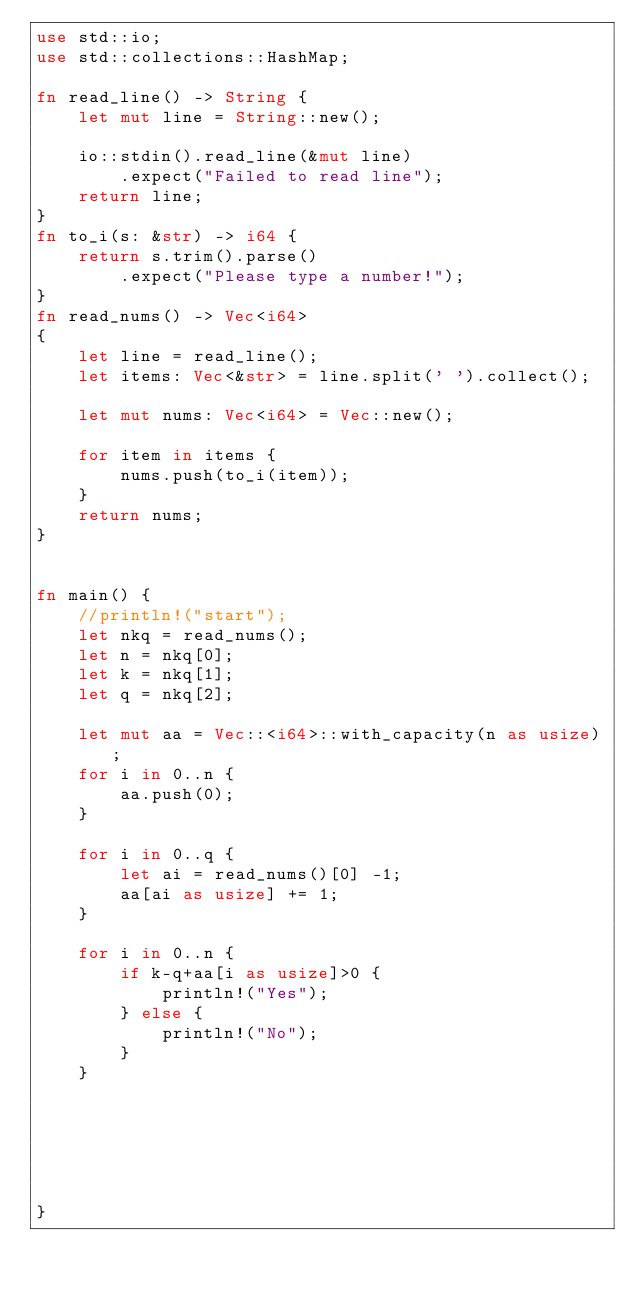Convert code to text. <code><loc_0><loc_0><loc_500><loc_500><_Rust_>use std::io;
use std::collections::HashMap;

fn read_line() -> String {
    let mut line = String::new();

    io::stdin().read_line(&mut line)
        .expect("Failed to read line");
    return line;
}
fn to_i(s: &str) -> i64 {
    return s.trim().parse()
        .expect("Please type a number!");
}
fn read_nums() -> Vec<i64>
{
    let line = read_line();
    let items: Vec<&str> = line.split(' ').collect();

    let mut nums: Vec<i64> = Vec::new();

    for item in items {
        nums.push(to_i(item));
    }
    return nums;
}


fn main() {
    //println!("start");
    let nkq = read_nums();
    let n = nkq[0];
    let k = nkq[1];
    let q = nkq[2];

    let mut aa = Vec::<i64>::with_capacity(n as usize);
    for i in 0..n {
        aa.push(0);
    }

    for i in 0..q {
        let ai = read_nums()[0] -1;
        aa[ai as usize] += 1;
    }

    for i in 0..n {
        if k-q+aa[i as usize]>0 {
            println!("Yes");
        } else {
            println!("No");
        }
    }


    
    
    
    
}   </code> 